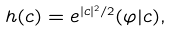Convert formula to latex. <formula><loc_0><loc_0><loc_500><loc_500>h ( c ) = e ^ { | c | ^ { 2 } / 2 } ( \varphi | c ) ,</formula> 